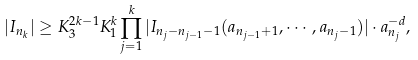<formula> <loc_0><loc_0><loc_500><loc_500>| I _ { n _ { k } } | \geq K _ { 3 } ^ { 2 k - 1 } K _ { 1 } ^ { k } \prod _ { j = 1 } ^ { k } | I _ { n _ { j } - n _ { j - 1 } - 1 } ( a _ { n _ { j - 1 } + 1 } , \cdots , a _ { n _ { j } - 1 } ) | \cdot a _ { n _ { j } } ^ { - d } ,</formula> 